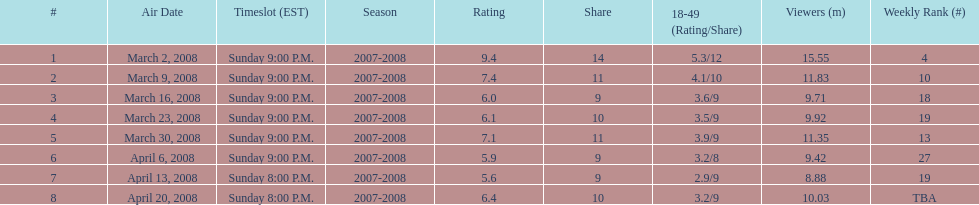Did the season wrap up at an earlier or later timeslot? Earlier. 